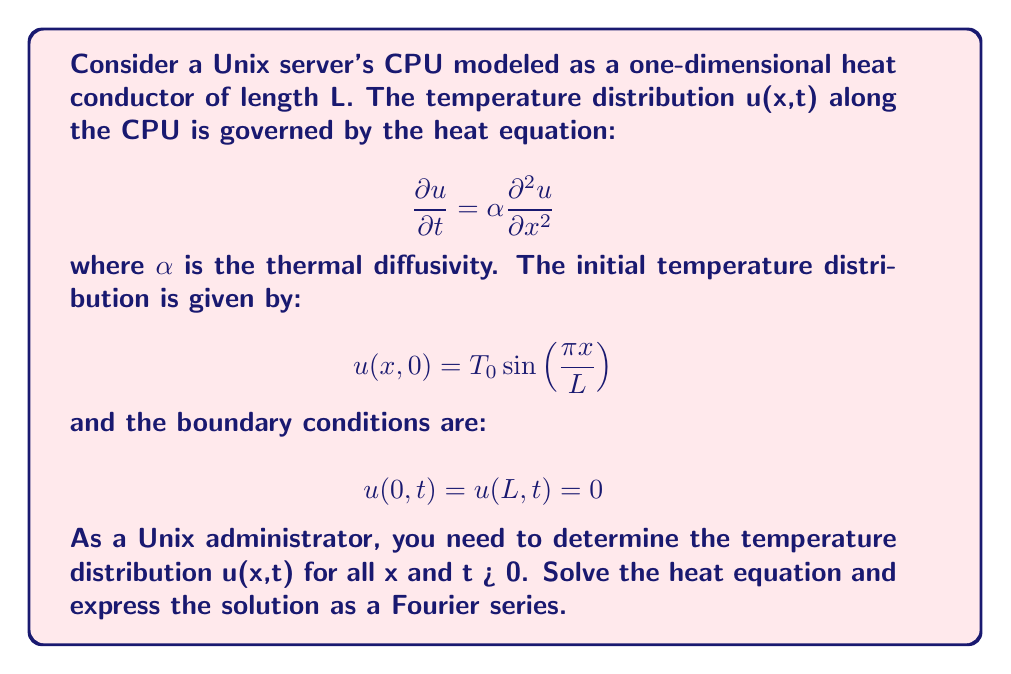Can you solve this math problem? To solve this heat equation problem, we'll follow these steps:

1) First, we assume a separation of variables solution of the form:
   $$ u(x,t) = X(x)T(t) $$

2) Substituting this into the heat equation:
   $$ X(x)T'(t) = \alpha X''(x)T(t) $$
   $$ \frac{T'(t)}{αT(t)} = \frac{X''(x)}{X(x)} = -λ^2 $$
   where -λ^2 is a separation constant.

3) This gives us two ordinary differential equations:
   $$ T'(t) + αλ^2T(t) = 0 $$
   $$ X''(x) + λ^2X(x) = 0 $$

4) The solution for T(t) is:
   $$ T(t) = ce^{-αλ^2t} $$

5) The solution for X(x), considering the boundary conditions, is:
   $$ X(x) = A\sin(\frac{nπx}{L}) $$
   where n is a positive integer.

6) Therefore, λ = nπ/L, and the general solution is:
   $$ u_n(x,t) = A_n\sin(\frac{nπx}{L})e^{-α(nπ/L)^2t} $$

7) The complete solution is a superposition of these solutions:
   $$ u(x,t) = \sum_{n=1}^{\infty} A_n\sin(\frac{nπx}{L})e^{-α(nπ/L)^2t} $$

8) To find A_n, we use the initial condition:
   $$ T_0\sin(\frac{πx}{L}) = \sum_{n=1}^{\infty} A_n\sin(\frac{nπx}{L}) $$

9) This is satisfied when n = 1 and A_1 = T_0, with all other A_n = 0.

Therefore, the final solution is:
$$ u(x,t) = T_0\sin(\frac{πx}{L})e^{-α(π/L)^2t} $$

This solution represents an efficient way to model the CPU temperature distribution, aligning with the Unix administrator's preference for elegance and efficiency.
Answer: $$ u(x,t) = T_0\sin(\frac{πx}{L})e^{-α(π/L)^2t} $$ 